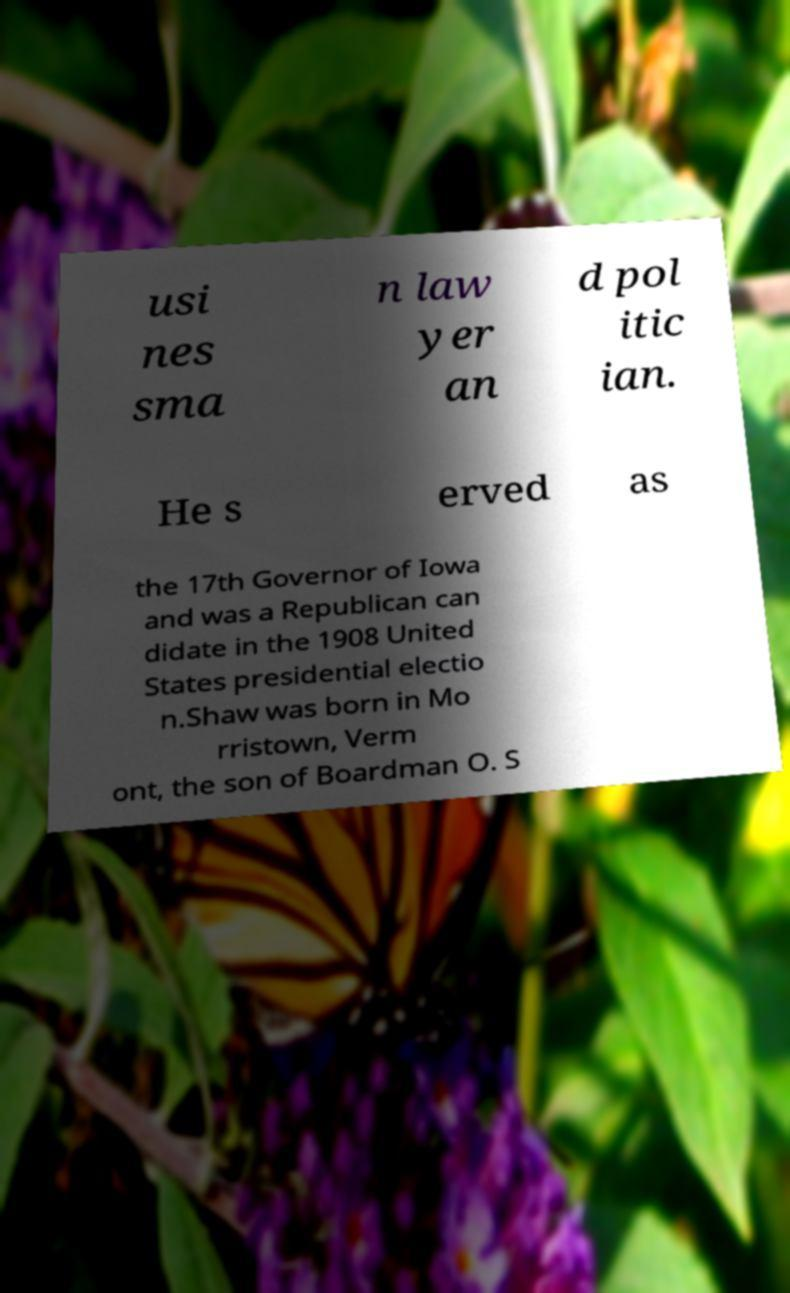Please read and relay the text visible in this image. What does it say? usi nes sma n law yer an d pol itic ian. He s erved as the 17th Governor of Iowa and was a Republican can didate in the 1908 United States presidential electio n.Shaw was born in Mo rristown, Verm ont, the son of Boardman O. S 